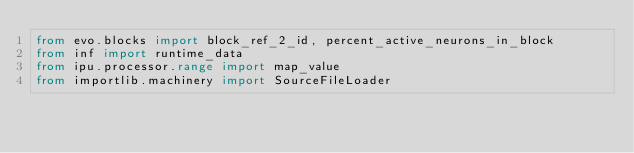Convert code to text. <code><loc_0><loc_0><loc_500><loc_500><_Python_>from evo.blocks import block_ref_2_id, percent_active_neurons_in_block
from inf import runtime_data
from ipu.processor.range import map_value
from importlib.machinery import SourceFileLoader

</code> 